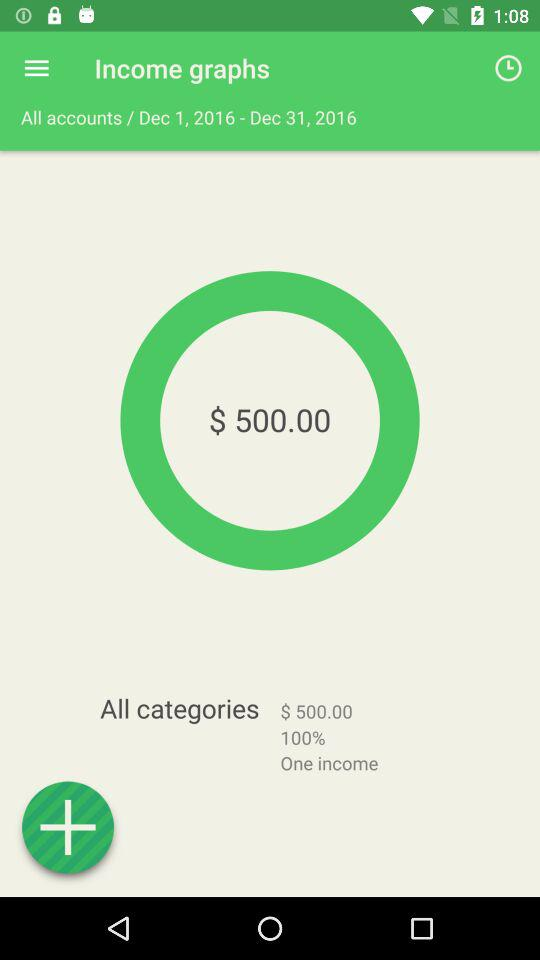What is the total income in terms of the percentage? The total income is 100 in terms of the percentage. 